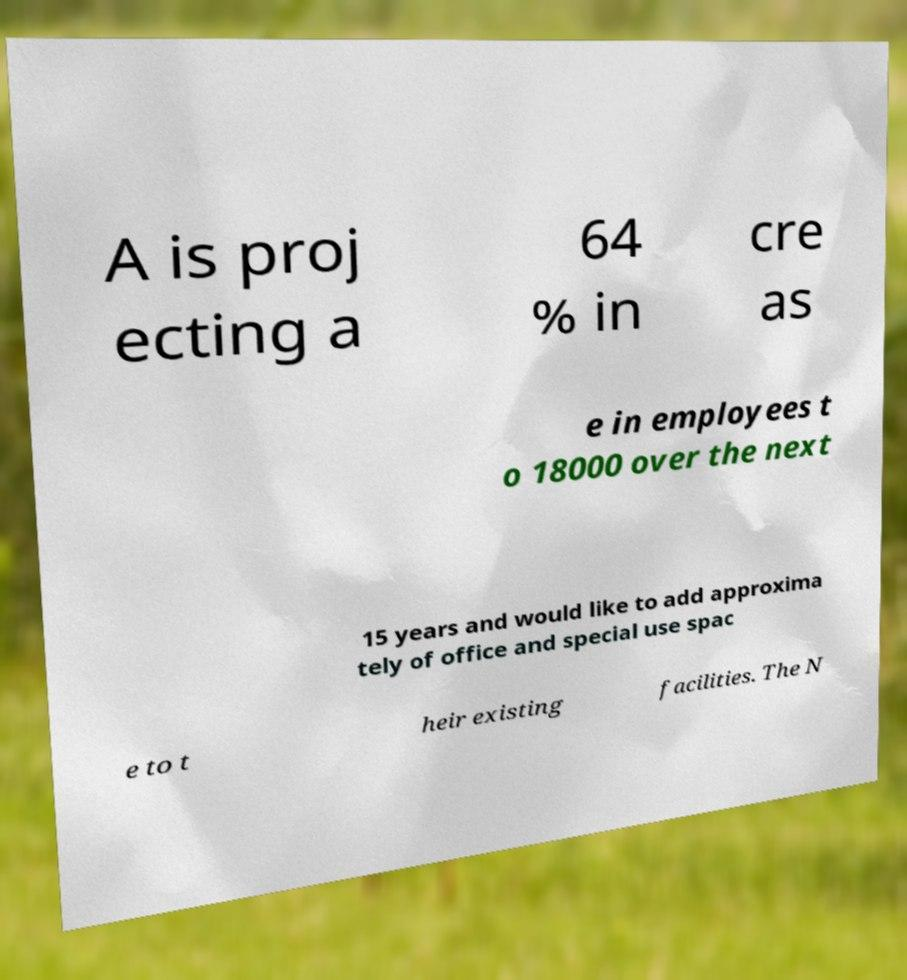I need the written content from this picture converted into text. Can you do that? A is proj ecting a 64 % in cre as e in employees t o 18000 over the next 15 years and would like to add approxima tely of office and special use spac e to t heir existing facilities. The N 